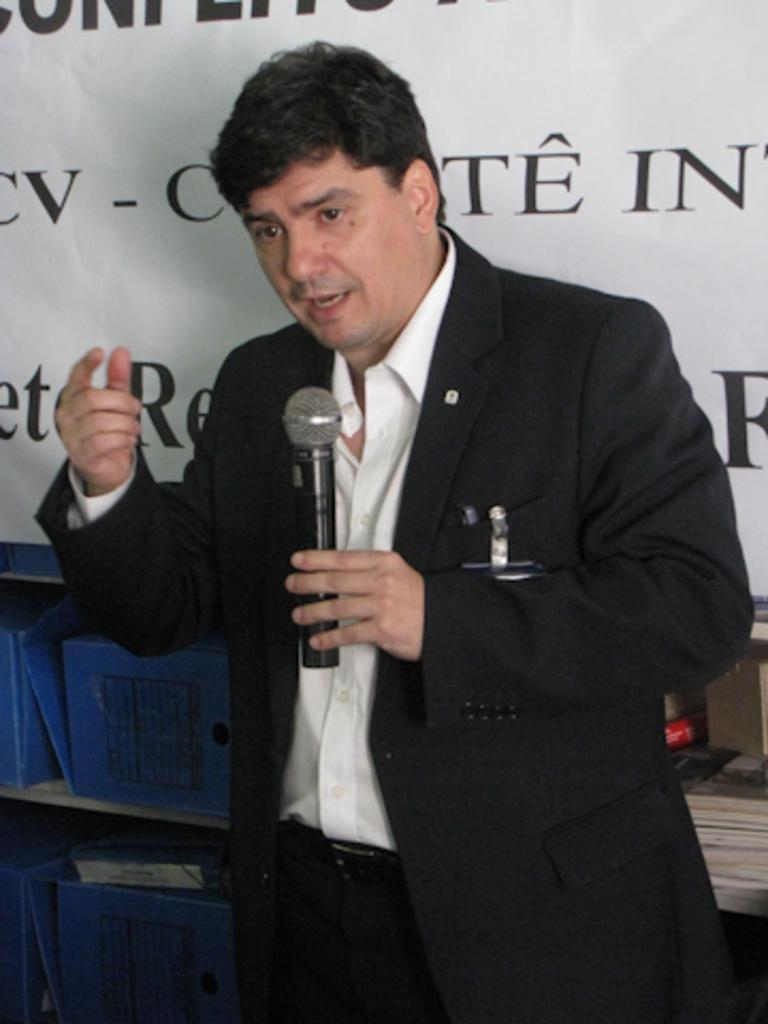What is the main subject of the image? The main subject of the image is a man. What is the man holding in the image? The man is holding a microphone. What is the man doing in the image? The man is speaking. What can be seen behind the man in the image? There is a banner behind the man. Can you see any crows perched on the banner in the image? There are no crows visible in the image. What type of feast is being prepared on the banner in the image? There is no feast or any reference to food on the banner in the image. 